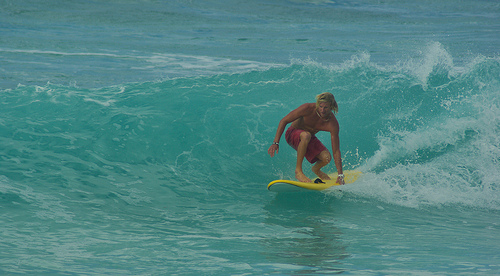What is the color of the shorts that the surfer is wearing? The shorts worn by the surfer are a striking red, contrasting vividly with the blue hues of the ocean. 